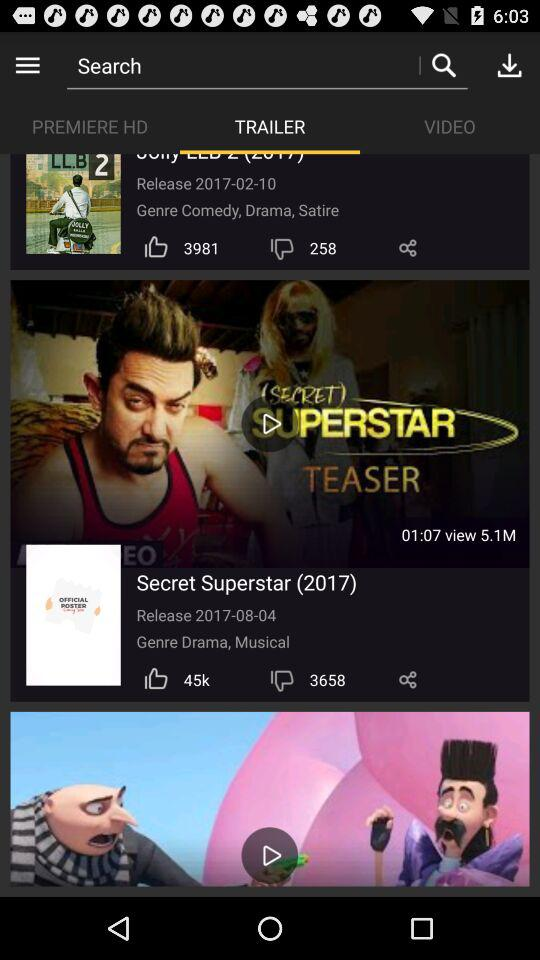What is the genre of "Secret Superstar"? The genre is "Drama, Musical". 